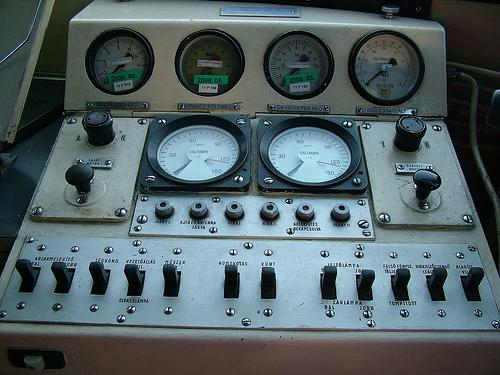Question: how many black switches are there?
Choices:
A. Three.
B. Four.
C. Twelve.
D. Five.
Answer with the letter. Answer: C Question: how many white clocks are there?
Choices:
A. Four.
B. Five.
C. Seven.
D. Six.
Answer with the letter. Answer: D Question: what color are clock's hands?
Choices:
A. Black.
B. White.
C. Red.
D. Gold.
Answer with the letter. Answer: A Question: how many green stickers are there?
Choices:
A. Four.
B. Five.
C. Six.
D. Three.
Answer with the letter. Answer: D Question: what is green?
Choices:
A. Trees.
B. Stickers.
C. Shrubs.
D. Grass.
Answer with the letter. Answer: B 